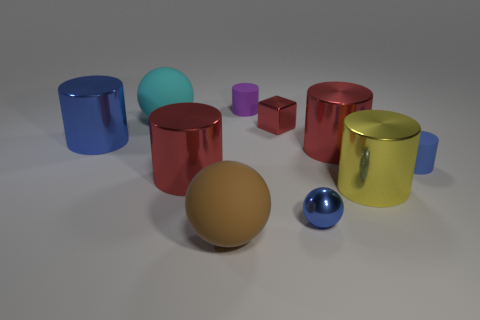Subtract all green spheres. How many blue cylinders are left? 2 Subtract all blue shiny cylinders. How many cylinders are left? 5 Subtract 1 spheres. How many spheres are left? 2 Subtract all blue cylinders. How many cylinders are left? 4 Subtract all spheres. How many objects are left? 7 Subtract all brown cylinders. Subtract all yellow spheres. How many cylinders are left? 6 Subtract 0 blue blocks. How many objects are left? 10 Subtract all large rubber balls. Subtract all large purple metal balls. How many objects are left? 8 Add 4 cyan rubber spheres. How many cyan rubber spheres are left? 5 Add 2 small blue spheres. How many small blue spheres exist? 3 